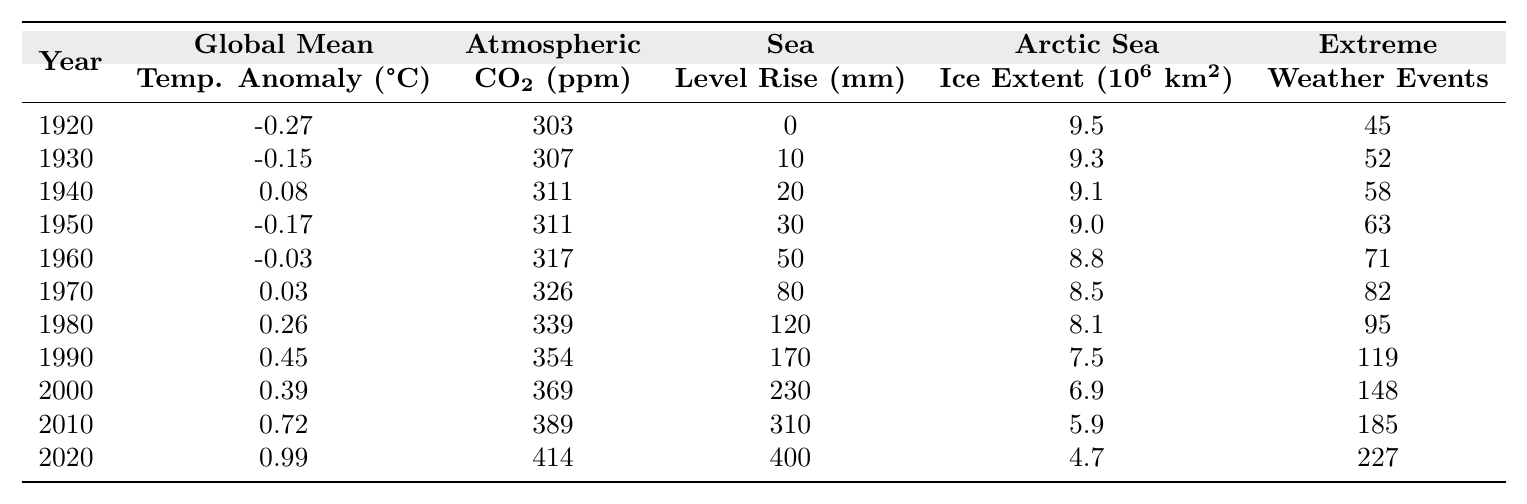What was the Global Mean Temperature Anomaly in 2010? The table shows that in 2010, the Global Mean Temperature Anomaly was reported as 0.72°C.
Answer: 0.72°C In which year did the Atmospheric CO2 Concentration first exceed 350 ppm? By examining the CO2 concentration values, it is clear that the first year to exceed 350 ppm was 1990, where the concentration was 354 ppm.
Answer: 1990 How much did the Sea Level Rise increase from 1920 to 2020? The Sea Level Rise in 1920 was 0 mm, and in 2020 it was 400 mm. The increase is 400 mm - 0 mm = 400 mm.
Answer: 400 mm What was the Arctic Sea Ice Extent in 2000? The table indicates that in 2000, the Arctic Sea Ice Extent was 6.9 million km².
Answer: 6.9 million km² What is the average count of Extreme Weather Events from 1920 to 2020? To find the average, we sum the events from each decade: 45 + 52 + 58 + 63 + 71 + 82 + 95 + 119 + 148 + 185 + 227 = 1070. There are 11 years, so the average is 1070/11 ≈ 97.27.
Answer: 97.27 Which decade saw the highest increase in Global Mean Temperature Anomaly compared to the previous decade? The highest increase is from the 2000s to the 2010s, where the temperature anomaly rose from 0.39°C to 0.72°C, an increase of 0.33°C.
Answer: 2000s to 2010s Was the Atmospheric CO2 Concentration higher in 1980 or 1990? In the table, the concentration for 1980 is 339 ppm and for 1990 is 354 ppm. Since 354 ppm is greater, it confirms that 1990 had a higher concentration.
Answer: Yes What is the trend in Arctic Sea Ice Extent from 1920 to 2020? Comparing the values, the Arctic Sea Ice Extent decreased from 9.5 million km² in 1920 to 4.7 million km² in 2020, showing a downward trend.
Answer: Decrease How many Extreme Weather Events were recorded in total from 1920 to 1970? The total counts for these years are: 45 + 52 + 58 + 63 + 71 + 82 = 371.
Answer: 371 What year had the highest Atmospheric CO2 Concentration and what was the value? The highest CO2 concentration was in 2020, where it reached 414 ppm.
Answer: 2020, 414 ppm If we consider the values of Global Mean Temperature Anomaly for the 1950s, what is the average? The recorded values for the 1950s are: -0.17°C (1950) and -0.03°C (1960). The average is calculated as (-0.17 + -0.03) / 2 = -0.10°C.
Answer: -0.10°C 